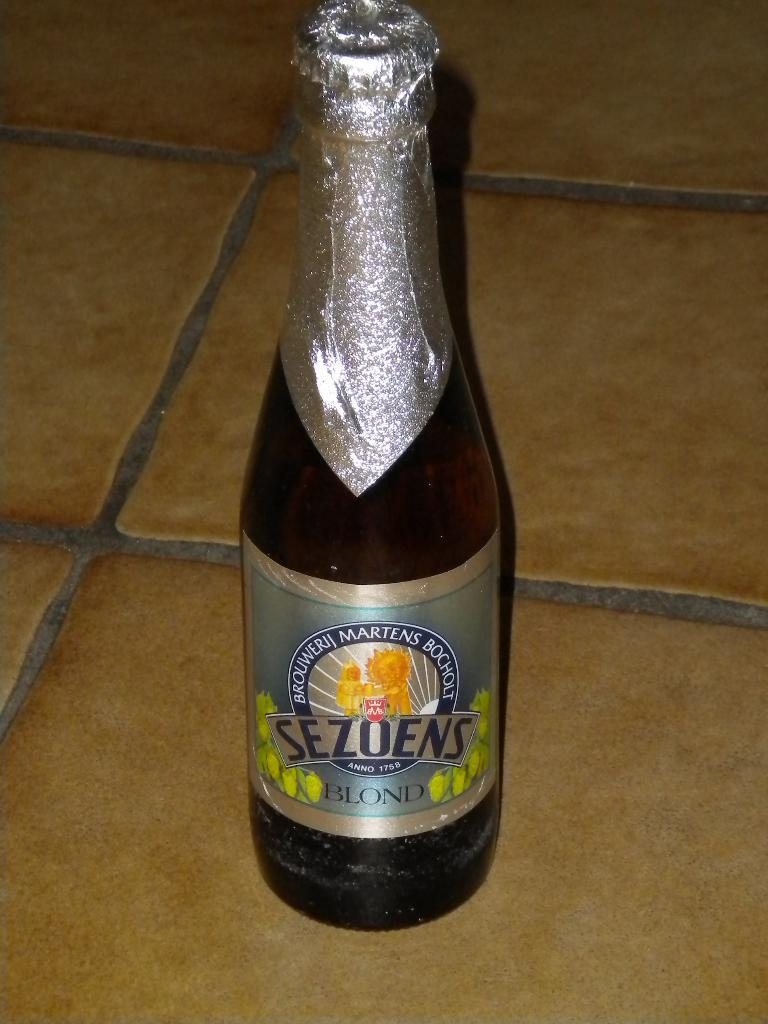<image>
Create a compact narrative representing the image presented. A bottle of "Sezoens Blond" is shown with a silver wrapping. 